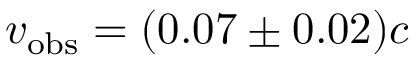<formula> <loc_0><loc_0><loc_500><loc_500>v _ { o b s } = ( 0 . 0 7 \pm 0 . 0 2 ) c</formula> 